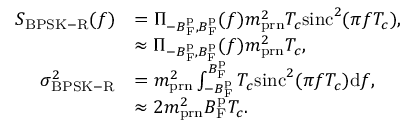Convert formula to latex. <formula><loc_0><loc_0><loc_500><loc_500>\begin{array} { r l } { S _ { B P S K - R } ( f ) } & { = \Pi _ { - B _ { F } ^ { p } , B _ { F } ^ { p } } ( f ) m _ { p r n } ^ { 2 } T _ { c } \sin c ^ { 2 } ( \pi f T _ { c } ) , } \\ & { \approx \Pi _ { - B _ { F } ^ { p } , B _ { F } ^ { p } } ( f ) m _ { p r n } ^ { 2 } T _ { c } , } \\ { \sigma _ { B P S K - R } ^ { 2 } } & { = m _ { p r n } ^ { 2 } \int _ { - B _ { F } ^ { p } } ^ { B _ { F } ^ { p } } T _ { c } \sin c ^ { 2 } ( \pi f T _ { c } ) d f , } \\ & { \approx 2 m _ { p r n } ^ { 2 } B _ { F } ^ { p } T _ { c } . } \end{array}</formula> 